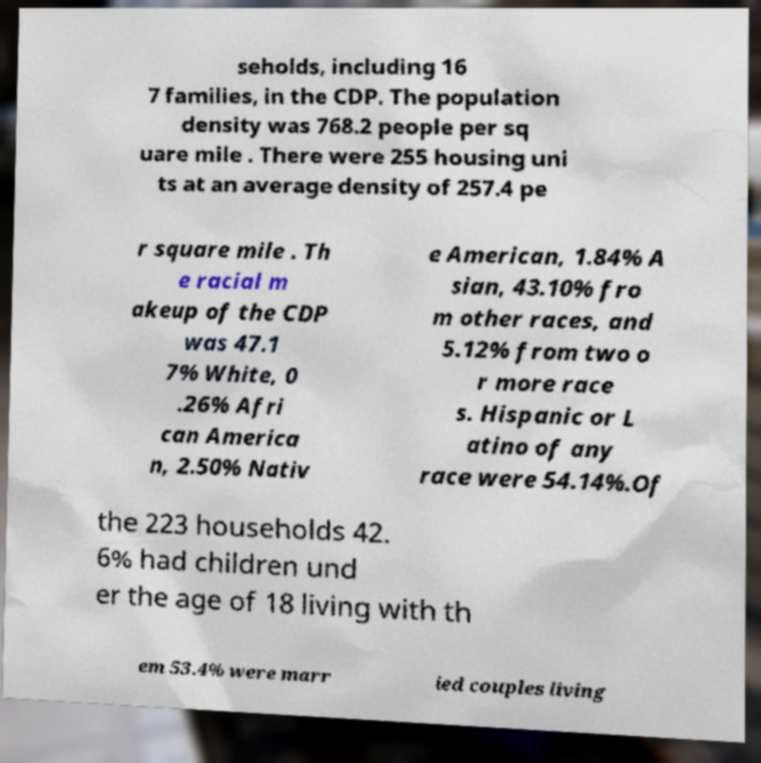Could you assist in decoding the text presented in this image and type it out clearly? seholds, including 16 7 families, in the CDP. The population density was 768.2 people per sq uare mile . There were 255 housing uni ts at an average density of 257.4 pe r square mile . Th e racial m akeup of the CDP was 47.1 7% White, 0 .26% Afri can America n, 2.50% Nativ e American, 1.84% A sian, 43.10% fro m other races, and 5.12% from two o r more race s. Hispanic or L atino of any race were 54.14%.Of the 223 households 42. 6% had children und er the age of 18 living with th em 53.4% were marr ied couples living 